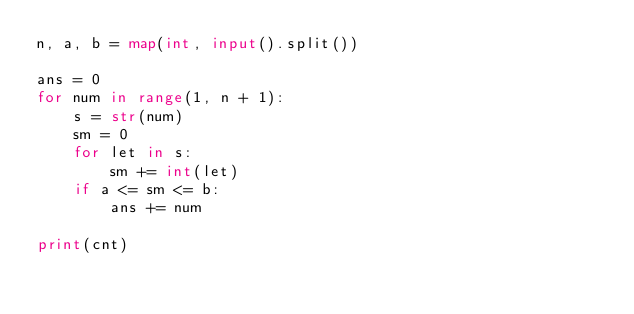Convert code to text. <code><loc_0><loc_0><loc_500><loc_500><_Python_>n, a, b = map(int, input().split())

ans = 0
for num in range(1, n + 1):
    s = str(num)
    sm = 0
    for let in s:
        sm += int(let)
    if a <= sm <= b:
        ans += num

print(cnt)
</code> 